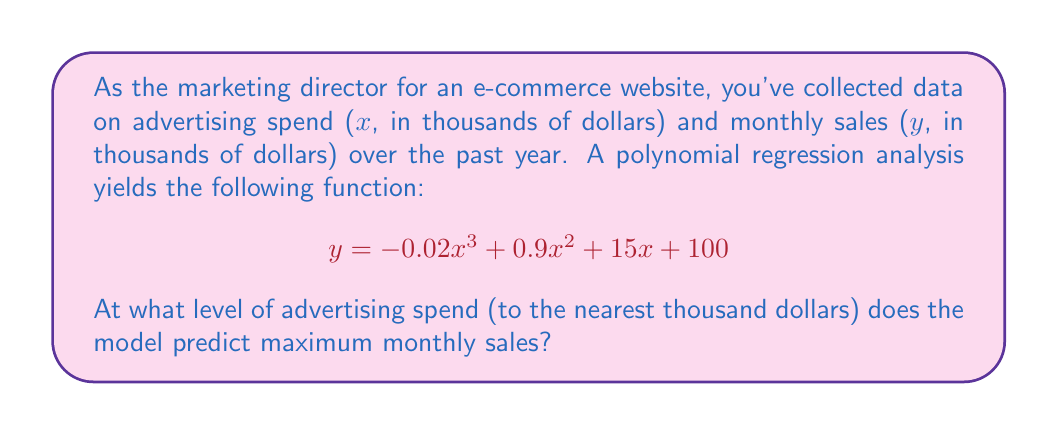What is the answer to this math problem? To find the maximum sales, we need to follow these steps:

1) The maximum point occurs where the derivative of the function is zero. Let's find the derivative:

   $$\frac{dy}{dx} = -0.06x^2 + 1.8x + 15$$

2) Set the derivative equal to zero:

   $$-0.06x^2 + 1.8x + 15 = 0$$

3) This is a quadratic equation. We can solve it using the quadratic formula:
   $$x = \frac{-b \pm \sqrt{b^2 - 4ac}}{2a}$$

   Where $a = -0.06$, $b = 1.8$, and $c = 15$

4) Plugging in these values:

   $$x = \frac{-1.8 \pm \sqrt{1.8^2 - 4(-0.06)(15)}}{2(-0.06)}$$

5) Simplifying:

   $$x = \frac{-1.8 \pm \sqrt{3.24 + 3.6}}{-0.12} = \frac{-1.8 \pm \sqrt{6.84}}{-0.12} = \frac{-1.8 \pm 2.615}{-0.12}$$

6) This gives us two solutions:
   
   $$x_1 = \frac{-1.8 + 2.615}{-0.12} \approx 6.79$$
   $$x_2 = \frac{-1.8 - 2.615}{-0.12} \approx 36.79$$

7) To determine which of these is the maximum (not minimum), we can check the second derivative:

   $$\frac{d^2y}{dx^2} = -0.12x + 1.8$$

   At $x = 36.79$, this is negative, indicating a maximum.

8) Therefore, the maximum occurs at approximately 36.79 thousand dollars.

9) Rounding to the nearest thousand dollars, we get 37 thousand dollars.
Answer: $37,000 